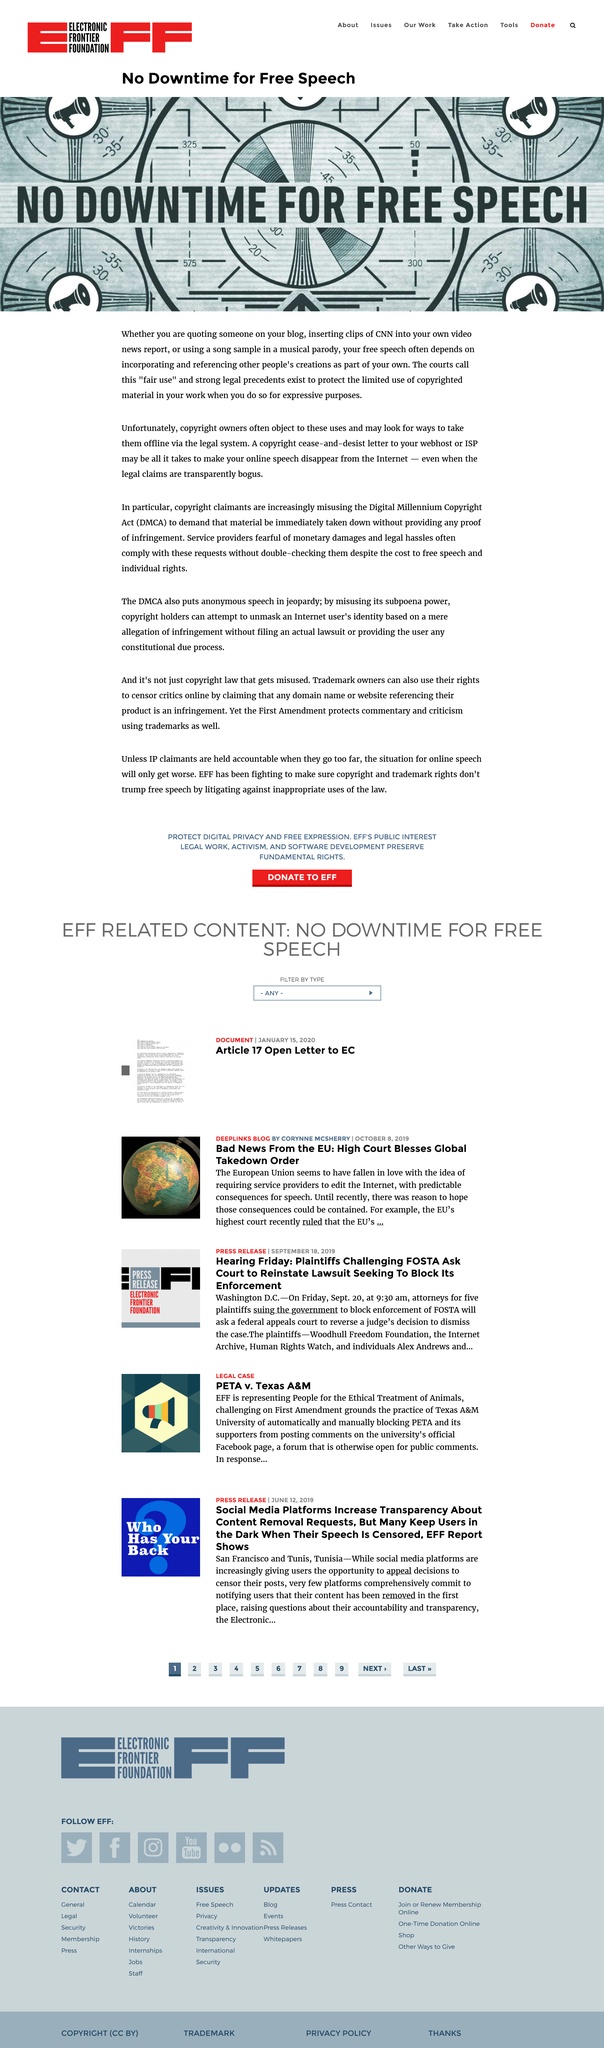Draw attention to some important aspects in this diagram. The image depicts the phrase "No downtime for free speech" in a clear and legible font. It is possible to remove online speech from the Internet through the use of a copyright cease-and-desist letter sent to the webhost or ISP. Copyright owners frequently take issue with the concept of "fair use. 